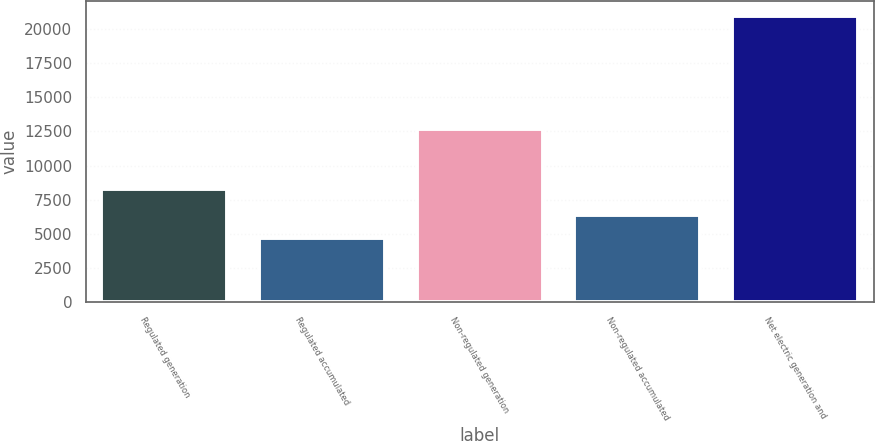<chart> <loc_0><loc_0><loc_500><loc_500><bar_chart><fcel>Regulated generation<fcel>Regulated accumulated<fcel>Non-regulated generation<fcel>Non-regulated accumulated<fcel>Net electric generation and<nl><fcel>8299<fcel>4732<fcel>12693<fcel>6358<fcel>20992<nl></chart> 